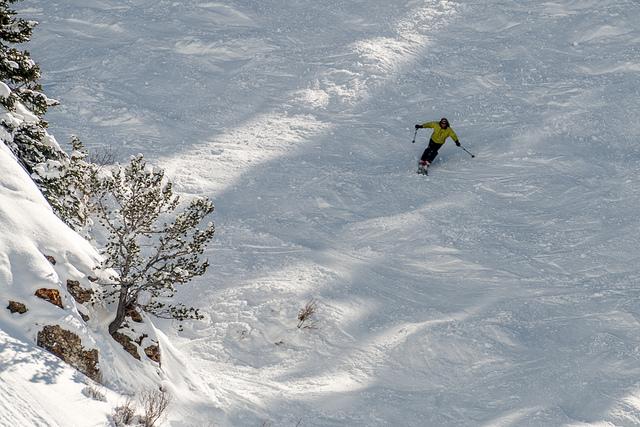What color is this skier's jacket?
Give a very brief answer. Yellow. Is there any stop sign in the picture?
Concise answer only. No. What color is the man's jacket?
Concise answer only. Yellow. Is this person surfing?
Quick response, please. No. Is the man skiing alone?
Give a very brief answer. Yes. What can be seen across the hole picture?
Quick response, please. Snow. How many skiers are there?
Quick response, please. 1. Is the man wearing a helmet?
Answer briefly. No. Is the tree without leaves dead?
Quick response, please. No. 